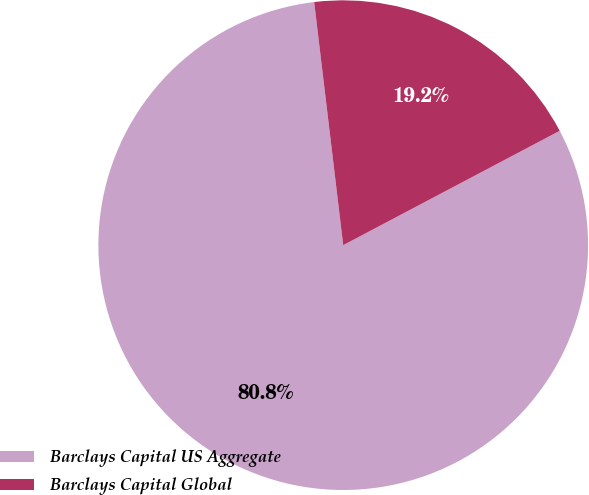Convert chart. <chart><loc_0><loc_0><loc_500><loc_500><pie_chart><fcel>Barclays Capital US Aggregate<fcel>Barclays Capital Global<nl><fcel>80.84%<fcel>19.16%<nl></chart> 